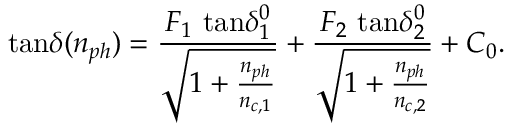<formula> <loc_0><loc_0><loc_500><loc_500>t a n \delta ( n _ { p h } ) = \frac { F _ { 1 } \ t a n \delta _ { 1 } ^ { 0 } } { \sqrt { 1 + \frac { n _ { p h } } { n _ { c , 1 } } } } + \frac { F _ { 2 } \ t a n \delta _ { 2 } ^ { 0 } } { \sqrt { 1 + \frac { n _ { p h } } { n _ { c , 2 } } } } + C _ { 0 } .</formula> 